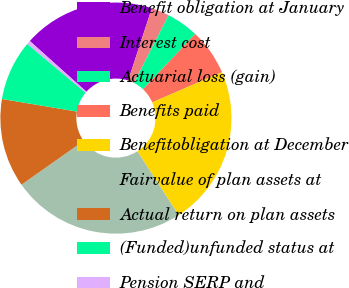Convert chart. <chart><loc_0><loc_0><loc_500><loc_500><pie_chart><fcel>Benefit obligation at January<fcel>Interest cost<fcel>Actuarial loss (gain)<fcel>Benefits paid<fcel>Benefitobligation at December<fcel>Fairvalue of plan assets at<fcel>Actual return on plan assets<fcel>(Funded)unfunded status at<fcel>Pension SERP and<nl><fcel>18.41%<fcel>2.51%<fcel>4.49%<fcel>6.47%<fcel>22.37%<fcel>24.35%<fcel>12.42%<fcel>8.45%<fcel>0.52%<nl></chart> 